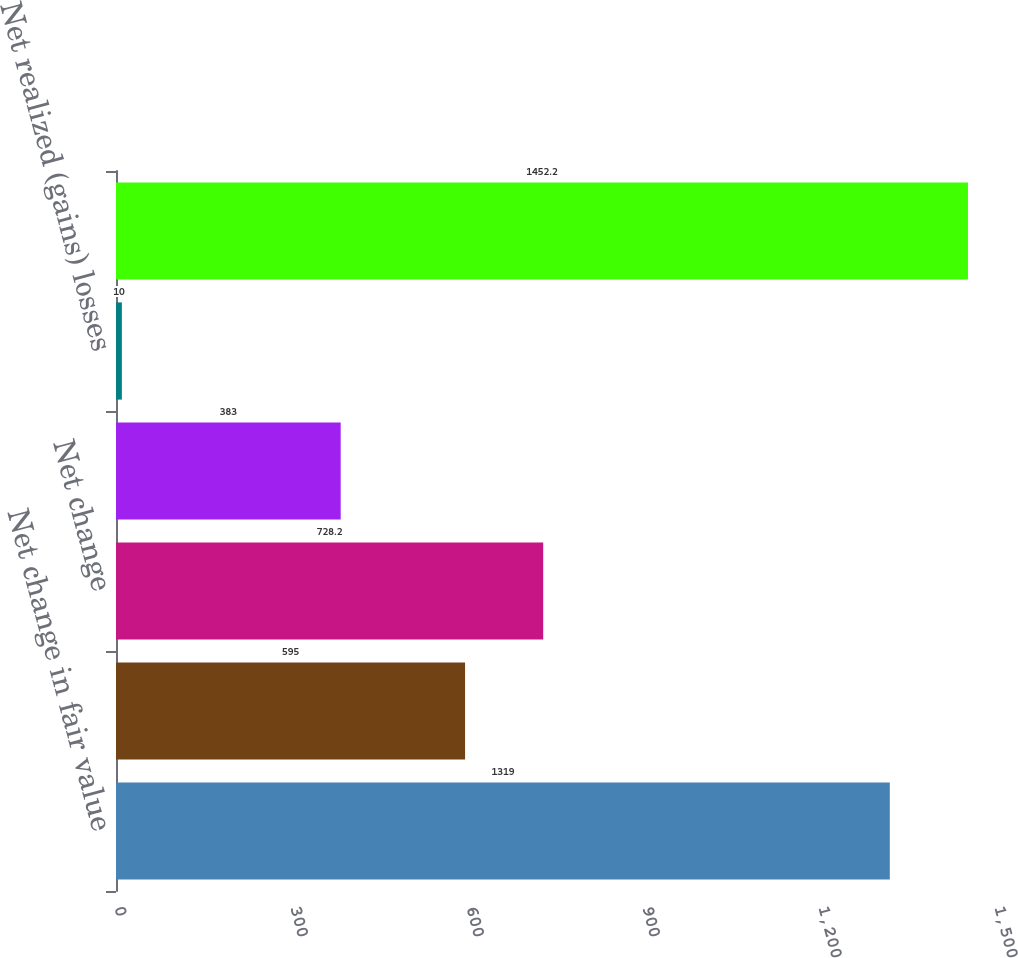<chart> <loc_0><loc_0><loc_500><loc_500><bar_chart><fcel>Net change in fair value<fcel>Net realized gains<fcel>Net change<fcel>Net realized losses<fcel>Net realized (gains) losses<fcel>Total other comprehensive<nl><fcel>1319<fcel>595<fcel>728.2<fcel>383<fcel>10<fcel>1452.2<nl></chart> 